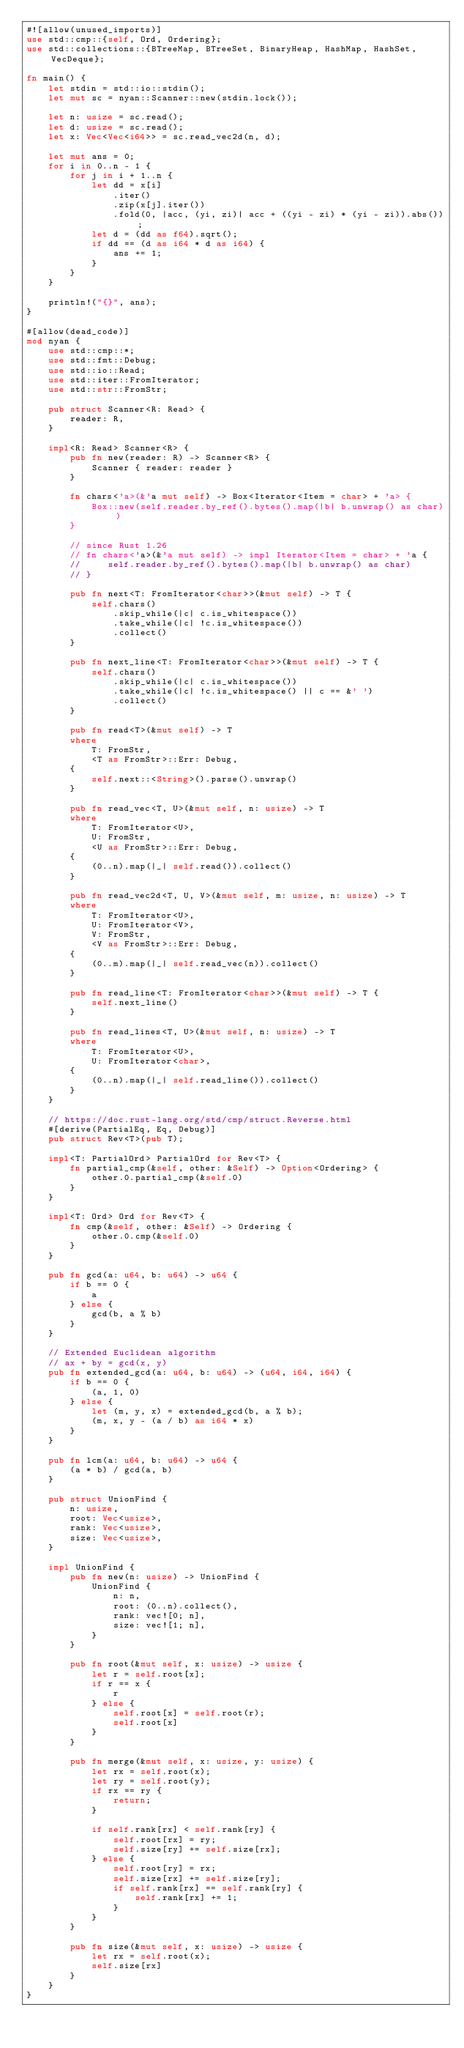Convert code to text. <code><loc_0><loc_0><loc_500><loc_500><_Rust_>#![allow(unused_imports)]
use std::cmp::{self, Ord, Ordering};
use std::collections::{BTreeMap, BTreeSet, BinaryHeap, HashMap, HashSet, VecDeque};

fn main() {
    let stdin = std::io::stdin();
    let mut sc = nyan::Scanner::new(stdin.lock());

    let n: usize = sc.read();
    let d: usize = sc.read();
    let x: Vec<Vec<i64>> = sc.read_vec2d(n, d);

    let mut ans = 0;
    for i in 0..n - 1 {
        for j in i + 1..n {
            let dd = x[i]
                .iter()
                .zip(x[j].iter())
                .fold(0, |acc, (yi, zi)| acc + ((yi - zi) * (yi - zi)).abs());
            let d = (dd as f64).sqrt();
            if dd == (d as i64 * d as i64) {
                ans += 1;
            }
        }
    }

    println!("{}", ans);
}

#[allow(dead_code)]
mod nyan {
    use std::cmp::*;
    use std::fmt::Debug;
    use std::io::Read;
    use std::iter::FromIterator;
    use std::str::FromStr;

    pub struct Scanner<R: Read> {
        reader: R,
    }

    impl<R: Read> Scanner<R> {
        pub fn new(reader: R) -> Scanner<R> {
            Scanner { reader: reader }
        }

        fn chars<'a>(&'a mut self) -> Box<Iterator<Item = char> + 'a> {
            Box::new(self.reader.by_ref().bytes().map(|b| b.unwrap() as char))
        }

        // since Rust 1.26
        // fn chars<'a>(&'a mut self) -> impl Iterator<Item = char> + 'a {
        //     self.reader.by_ref().bytes().map(|b| b.unwrap() as char)
        // }

        pub fn next<T: FromIterator<char>>(&mut self) -> T {
            self.chars()
                .skip_while(|c| c.is_whitespace())
                .take_while(|c| !c.is_whitespace())
                .collect()
        }

        pub fn next_line<T: FromIterator<char>>(&mut self) -> T {
            self.chars()
                .skip_while(|c| c.is_whitespace())
                .take_while(|c| !c.is_whitespace() || c == &' ')
                .collect()
        }

        pub fn read<T>(&mut self) -> T
        where
            T: FromStr,
            <T as FromStr>::Err: Debug,
        {
            self.next::<String>().parse().unwrap()
        }

        pub fn read_vec<T, U>(&mut self, n: usize) -> T
        where
            T: FromIterator<U>,
            U: FromStr,
            <U as FromStr>::Err: Debug,
        {
            (0..n).map(|_| self.read()).collect()
        }

        pub fn read_vec2d<T, U, V>(&mut self, m: usize, n: usize) -> T
        where
            T: FromIterator<U>,
            U: FromIterator<V>,
            V: FromStr,
            <V as FromStr>::Err: Debug,
        {
            (0..m).map(|_| self.read_vec(n)).collect()
        }

        pub fn read_line<T: FromIterator<char>>(&mut self) -> T {
            self.next_line()
        }

        pub fn read_lines<T, U>(&mut self, n: usize) -> T
        where
            T: FromIterator<U>,
            U: FromIterator<char>,
        {
            (0..n).map(|_| self.read_line()).collect()
        }
    }

    // https://doc.rust-lang.org/std/cmp/struct.Reverse.html
    #[derive(PartialEq, Eq, Debug)]
    pub struct Rev<T>(pub T);

    impl<T: PartialOrd> PartialOrd for Rev<T> {
        fn partial_cmp(&self, other: &Self) -> Option<Ordering> {
            other.0.partial_cmp(&self.0)
        }
    }

    impl<T: Ord> Ord for Rev<T> {
        fn cmp(&self, other: &Self) -> Ordering {
            other.0.cmp(&self.0)
        }
    }

    pub fn gcd(a: u64, b: u64) -> u64 {
        if b == 0 {
            a
        } else {
            gcd(b, a % b)
        }
    }

    // Extended Euclidean algorithm
    // ax + by = gcd(x, y)
    pub fn extended_gcd(a: u64, b: u64) -> (u64, i64, i64) {
        if b == 0 {
            (a, 1, 0)
        } else {
            let (m, y, x) = extended_gcd(b, a % b);
            (m, x, y - (a / b) as i64 * x)
        }
    }

    pub fn lcm(a: u64, b: u64) -> u64 {
        (a * b) / gcd(a, b)
    }

    pub struct UnionFind {
        n: usize,
        root: Vec<usize>,
        rank: Vec<usize>,
        size: Vec<usize>,
    }

    impl UnionFind {
        pub fn new(n: usize) -> UnionFind {
            UnionFind {
                n: n,
                root: (0..n).collect(),
                rank: vec![0; n],
                size: vec![1; n],
            }
        }

        pub fn root(&mut self, x: usize) -> usize {
            let r = self.root[x];
            if r == x {
                r
            } else {
                self.root[x] = self.root(r);
                self.root[x]
            }
        }

        pub fn merge(&mut self, x: usize, y: usize) {
            let rx = self.root(x);
            let ry = self.root(y);
            if rx == ry {
                return;
            }

            if self.rank[rx] < self.rank[ry] {
                self.root[rx] = ry;
                self.size[ry] += self.size[rx];
            } else {
                self.root[ry] = rx;
                self.size[rx] += self.size[ry];
                if self.rank[rx] == self.rank[ry] {
                    self.rank[rx] += 1;
                }
            }
        }

        pub fn size(&mut self, x: usize) -> usize {
            let rx = self.root(x);
            self.size[rx]
        }
    }
}
</code> 